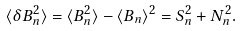Convert formula to latex. <formula><loc_0><loc_0><loc_500><loc_500>\langle \delta B _ { n } ^ { 2 } \rangle = \langle B _ { n } ^ { 2 } \rangle - \langle B _ { n } \rangle ^ { 2 } = S _ { n } ^ { 2 } + N _ { n } ^ { 2 } .</formula> 